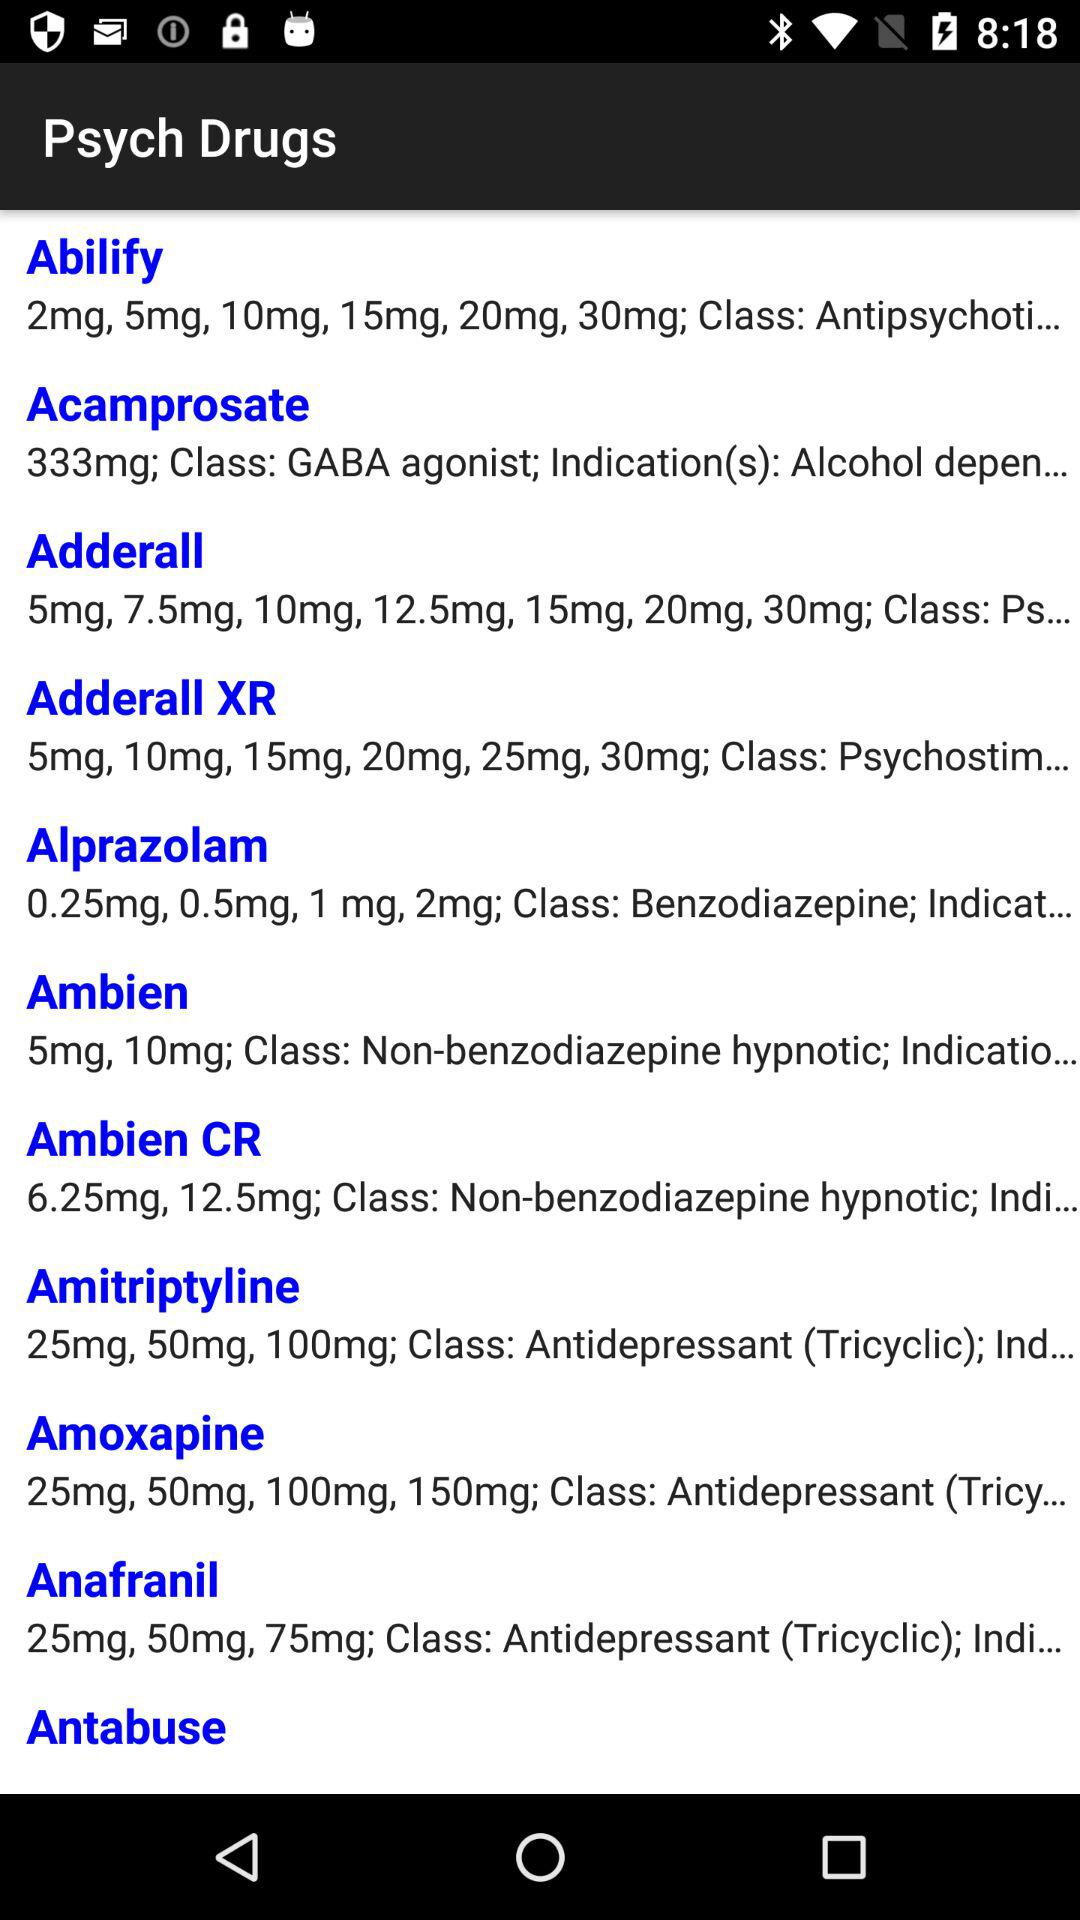What is the name of the drug whose class is "GABA agonist"? The name of the drug is "Acamprosate". 